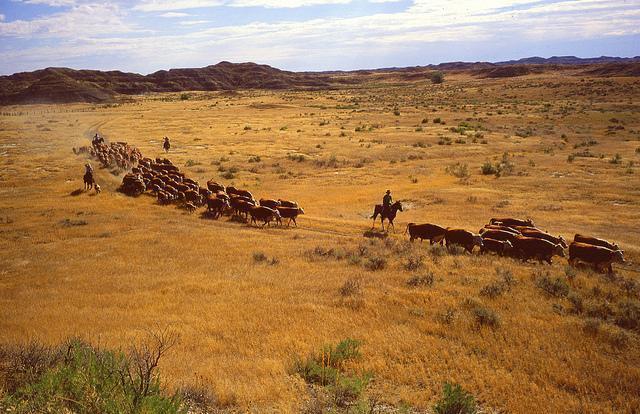How many horses are there?
Give a very brief answer. 4. How many elephants are male?
Give a very brief answer. 0. 